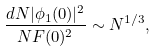<formula> <loc_0><loc_0><loc_500><loc_500>\frac { d N | \phi _ { 1 } ( 0 ) | ^ { 2 } } { N F ( 0 ) ^ { 2 } } \sim N ^ { 1 / 3 } ,</formula> 